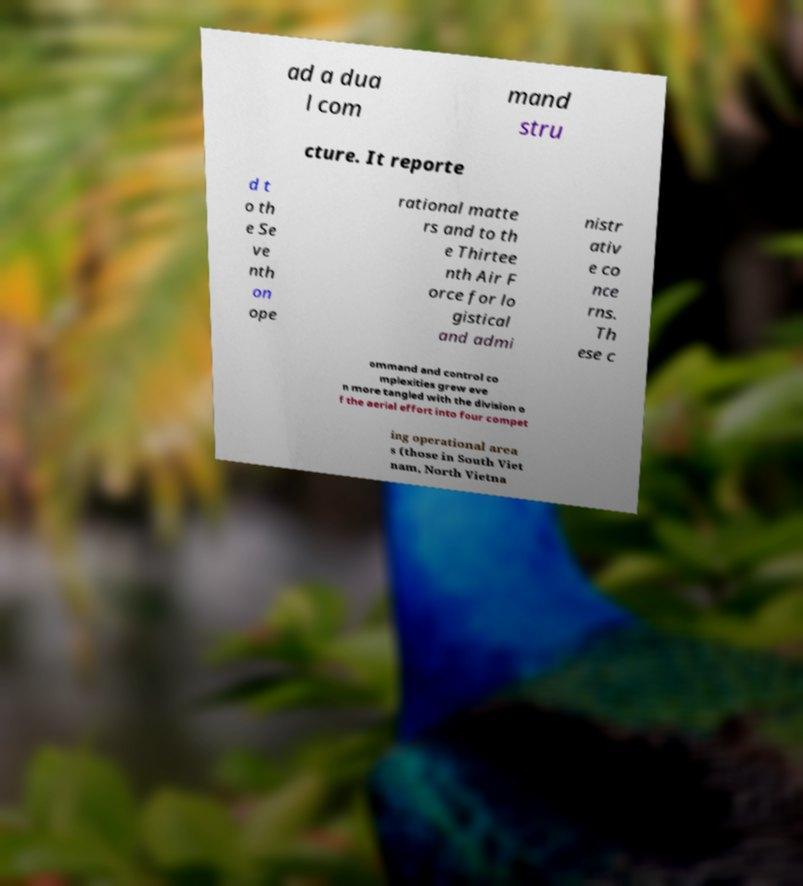What messages or text are displayed in this image? I need them in a readable, typed format. ad a dua l com mand stru cture. It reporte d t o th e Se ve nth on ope rational matte rs and to th e Thirtee nth Air F orce for lo gistical and admi nistr ativ e co nce rns. Th ese c ommand and control co mplexities grew eve n more tangled with the division o f the aerial effort into four compet ing operational area s (those in South Viet nam, North Vietna 